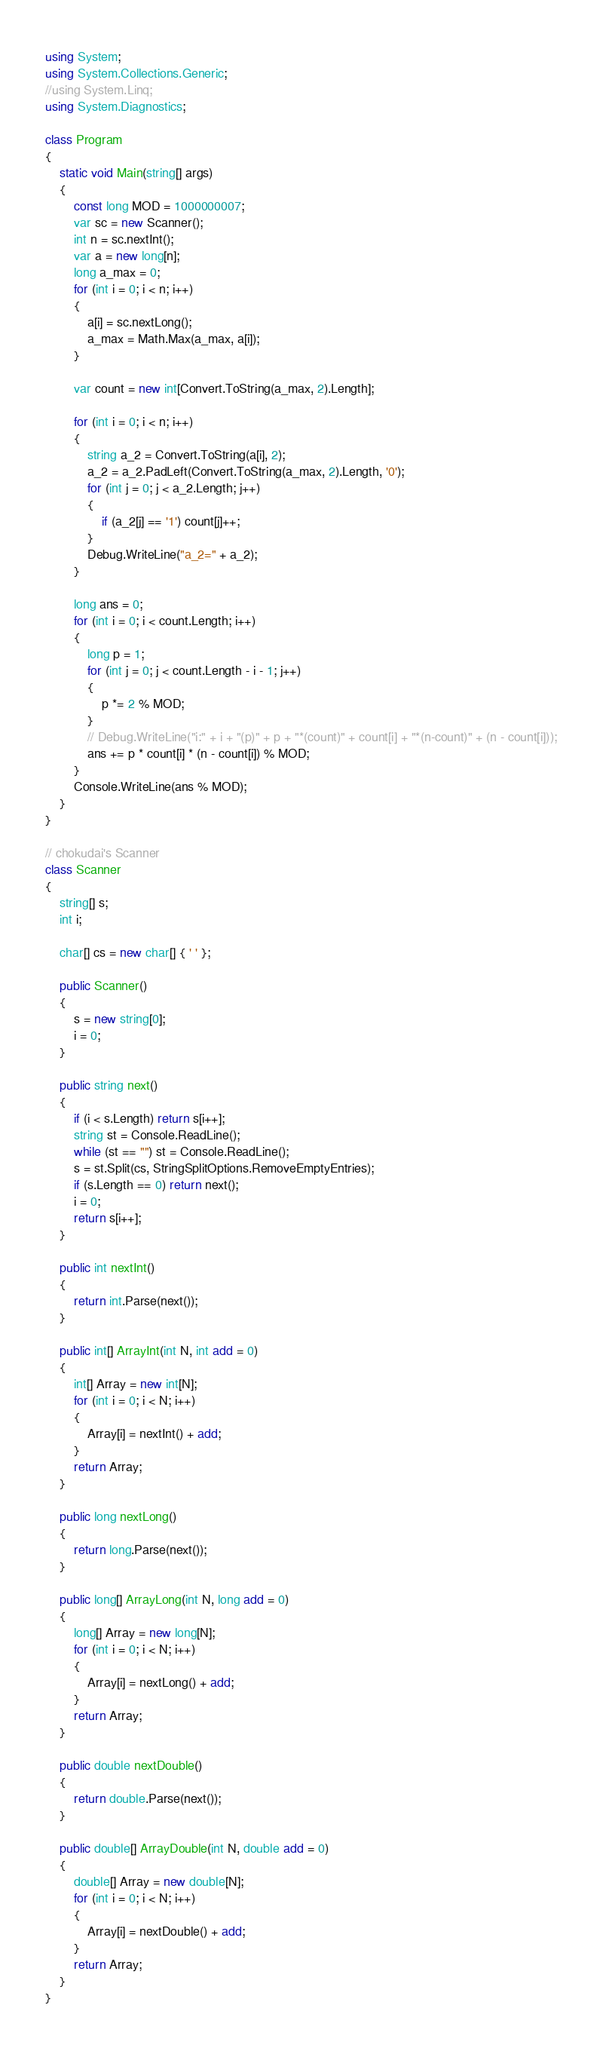Convert code to text. <code><loc_0><loc_0><loc_500><loc_500><_C#_>using System;
using System.Collections.Generic;
//using System.Linq;
using System.Diagnostics;

class Program
{
    static void Main(string[] args)
    {
        const long MOD = 1000000007;
        var sc = new Scanner();
        int n = sc.nextInt();
        var a = new long[n];
        long a_max = 0;
        for (int i = 0; i < n; i++)
        {
            a[i] = sc.nextLong();
            a_max = Math.Max(a_max, a[i]);
        }

        var count = new int[Convert.ToString(a_max, 2).Length];

        for (int i = 0; i < n; i++)
        {
            string a_2 = Convert.ToString(a[i], 2);
            a_2 = a_2.PadLeft(Convert.ToString(a_max, 2).Length, '0');
            for (int j = 0; j < a_2.Length; j++)
            {
                if (a_2[j] == '1') count[j]++;
            }
            Debug.WriteLine("a_2=" + a_2);
        }

        long ans = 0;
        for (int i = 0; i < count.Length; i++)
        {
            long p = 1;
            for (int j = 0; j < count.Length - i - 1; j++)
            {
                p *= 2 % MOD;
            }
            // Debug.WriteLine("i:" + i + "(p)" + p + "*(count)" + count[i] + "*(n-count)" + (n - count[i]));
            ans += p * count[i] * (n - count[i]) % MOD;
        }
        Console.WriteLine(ans % MOD);
    }
}

// chokudai's Scanner
class Scanner
{
    string[] s;
    int i;

    char[] cs = new char[] { ' ' };

    public Scanner()
    {
        s = new string[0];
        i = 0;
    }

    public string next()
    {
        if (i < s.Length) return s[i++];
        string st = Console.ReadLine();
        while (st == "") st = Console.ReadLine();
        s = st.Split(cs, StringSplitOptions.RemoveEmptyEntries);
        if (s.Length == 0) return next();
        i = 0;
        return s[i++];
    }

    public int nextInt()
    {
        return int.Parse(next());
    }

    public int[] ArrayInt(int N, int add = 0)
    {
        int[] Array = new int[N];
        for (int i = 0; i < N; i++)
        {
            Array[i] = nextInt() + add;
        }
        return Array;
    }

    public long nextLong()
    {
        return long.Parse(next());
    }

    public long[] ArrayLong(int N, long add = 0)
    {
        long[] Array = new long[N];
        for (int i = 0; i < N; i++)
        {
            Array[i] = nextLong() + add;
        }
        return Array;
    }

    public double nextDouble()
    {
        return double.Parse(next());
    }

    public double[] ArrayDouble(int N, double add = 0)
    {
        double[] Array = new double[N];
        for (int i = 0; i < N; i++)
        {
            Array[i] = nextDouble() + add;
        }
        return Array;
    }
}
</code> 